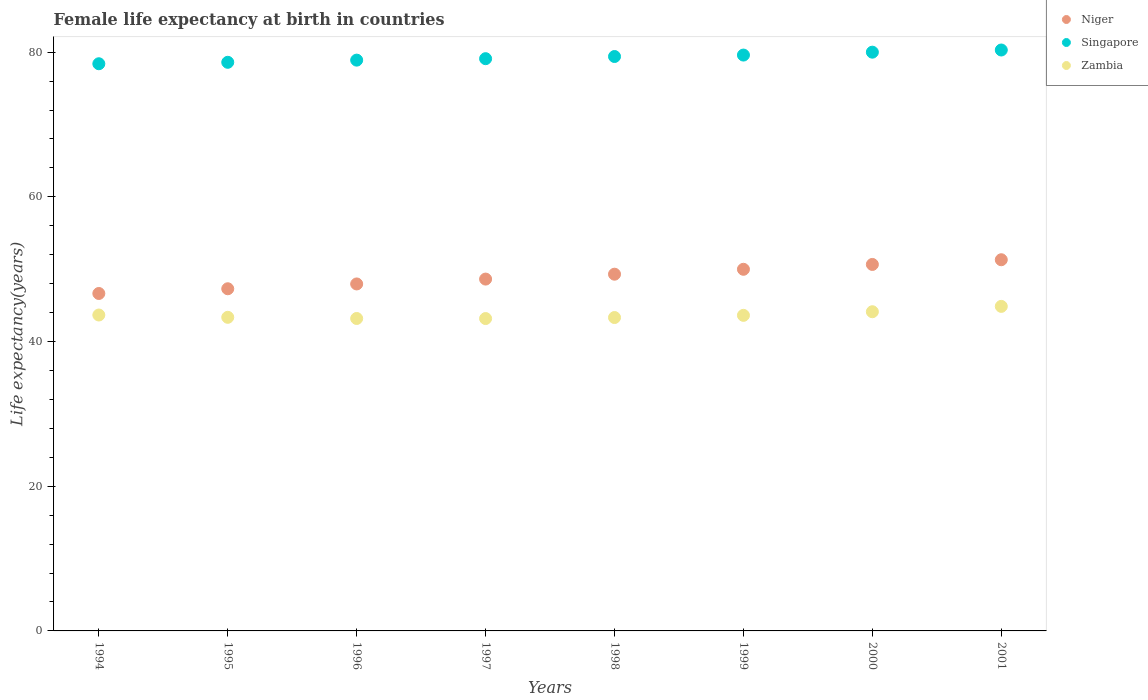How many different coloured dotlines are there?
Provide a short and direct response. 3. Is the number of dotlines equal to the number of legend labels?
Provide a short and direct response. Yes. What is the female life expectancy at birth in Niger in 1999?
Your response must be concise. 49.99. Across all years, what is the maximum female life expectancy at birth in Zambia?
Provide a succinct answer. 44.86. Across all years, what is the minimum female life expectancy at birth in Niger?
Keep it short and to the point. 46.64. In which year was the female life expectancy at birth in Singapore maximum?
Offer a very short reply. 2001. In which year was the female life expectancy at birth in Zambia minimum?
Your answer should be very brief. 1997. What is the total female life expectancy at birth in Zambia in the graph?
Make the answer very short. 349.31. What is the difference between the female life expectancy at birth in Niger in 1994 and that in 2000?
Make the answer very short. -4.01. What is the difference between the female life expectancy at birth in Niger in 1999 and the female life expectancy at birth in Singapore in 1996?
Your response must be concise. -28.91. What is the average female life expectancy at birth in Zambia per year?
Make the answer very short. 43.66. In the year 1996, what is the difference between the female life expectancy at birth in Zambia and female life expectancy at birth in Singapore?
Your answer should be compact. -35.71. In how many years, is the female life expectancy at birth in Niger greater than 32 years?
Your answer should be compact. 8. What is the ratio of the female life expectancy at birth in Zambia in 1996 to that in 1997?
Your response must be concise. 1. What is the difference between the highest and the second highest female life expectancy at birth in Singapore?
Your answer should be compact. 0.3. What is the difference between the highest and the lowest female life expectancy at birth in Zambia?
Keep it short and to the point. 1.68. Is the sum of the female life expectancy at birth in Niger in 1994 and 1997 greater than the maximum female life expectancy at birth in Zambia across all years?
Provide a short and direct response. Yes. Is the female life expectancy at birth in Singapore strictly less than the female life expectancy at birth in Niger over the years?
Provide a succinct answer. No. How many legend labels are there?
Offer a very short reply. 3. How are the legend labels stacked?
Your response must be concise. Vertical. What is the title of the graph?
Provide a succinct answer. Female life expectancy at birth in countries. Does "American Samoa" appear as one of the legend labels in the graph?
Offer a terse response. No. What is the label or title of the Y-axis?
Your answer should be compact. Life expectancy(years). What is the Life expectancy(years) of Niger in 1994?
Provide a short and direct response. 46.64. What is the Life expectancy(years) in Singapore in 1994?
Provide a succinct answer. 78.4. What is the Life expectancy(years) of Zambia in 1994?
Offer a terse response. 43.67. What is the Life expectancy(years) of Niger in 1995?
Make the answer very short. 47.3. What is the Life expectancy(years) of Singapore in 1995?
Your answer should be compact. 78.6. What is the Life expectancy(years) of Zambia in 1995?
Ensure brevity in your answer.  43.35. What is the Life expectancy(years) of Niger in 1996?
Give a very brief answer. 47.96. What is the Life expectancy(years) of Singapore in 1996?
Give a very brief answer. 78.9. What is the Life expectancy(years) in Zambia in 1996?
Provide a succinct answer. 43.19. What is the Life expectancy(years) in Niger in 1997?
Give a very brief answer. 48.63. What is the Life expectancy(years) in Singapore in 1997?
Offer a terse response. 79.1. What is the Life expectancy(years) of Zambia in 1997?
Your answer should be compact. 43.18. What is the Life expectancy(years) in Niger in 1998?
Make the answer very short. 49.31. What is the Life expectancy(years) of Singapore in 1998?
Offer a very short reply. 79.4. What is the Life expectancy(years) in Zambia in 1998?
Ensure brevity in your answer.  43.32. What is the Life expectancy(years) in Niger in 1999?
Offer a terse response. 49.99. What is the Life expectancy(years) of Singapore in 1999?
Offer a very short reply. 79.6. What is the Life expectancy(years) of Zambia in 1999?
Offer a terse response. 43.62. What is the Life expectancy(years) of Niger in 2000?
Provide a succinct answer. 50.66. What is the Life expectancy(years) in Zambia in 2000?
Your response must be concise. 44.12. What is the Life expectancy(years) in Niger in 2001?
Provide a short and direct response. 51.31. What is the Life expectancy(years) in Singapore in 2001?
Make the answer very short. 80.3. What is the Life expectancy(years) in Zambia in 2001?
Make the answer very short. 44.86. Across all years, what is the maximum Life expectancy(years) of Niger?
Provide a short and direct response. 51.31. Across all years, what is the maximum Life expectancy(years) in Singapore?
Give a very brief answer. 80.3. Across all years, what is the maximum Life expectancy(years) of Zambia?
Your response must be concise. 44.86. Across all years, what is the minimum Life expectancy(years) of Niger?
Your answer should be compact. 46.64. Across all years, what is the minimum Life expectancy(years) in Singapore?
Your answer should be compact. 78.4. Across all years, what is the minimum Life expectancy(years) in Zambia?
Make the answer very short. 43.18. What is the total Life expectancy(years) of Niger in the graph?
Ensure brevity in your answer.  391.8. What is the total Life expectancy(years) in Singapore in the graph?
Offer a terse response. 634.3. What is the total Life expectancy(years) of Zambia in the graph?
Your answer should be compact. 349.31. What is the difference between the Life expectancy(years) of Niger in 1994 and that in 1995?
Offer a terse response. -0.65. What is the difference between the Life expectancy(years) in Singapore in 1994 and that in 1995?
Provide a short and direct response. -0.2. What is the difference between the Life expectancy(years) in Zambia in 1994 and that in 1995?
Your answer should be compact. 0.32. What is the difference between the Life expectancy(years) of Niger in 1994 and that in 1996?
Keep it short and to the point. -1.32. What is the difference between the Life expectancy(years) in Singapore in 1994 and that in 1996?
Provide a succinct answer. -0.5. What is the difference between the Life expectancy(years) in Zambia in 1994 and that in 1996?
Keep it short and to the point. 0.48. What is the difference between the Life expectancy(years) in Niger in 1994 and that in 1997?
Make the answer very short. -1.99. What is the difference between the Life expectancy(years) in Zambia in 1994 and that in 1997?
Provide a succinct answer. 0.49. What is the difference between the Life expectancy(years) in Niger in 1994 and that in 1998?
Your answer should be very brief. -2.67. What is the difference between the Life expectancy(years) of Zambia in 1994 and that in 1998?
Offer a very short reply. 0.35. What is the difference between the Life expectancy(years) of Niger in 1994 and that in 1999?
Your answer should be very brief. -3.34. What is the difference between the Life expectancy(years) of Zambia in 1994 and that in 1999?
Your response must be concise. 0.05. What is the difference between the Life expectancy(years) of Niger in 1994 and that in 2000?
Offer a very short reply. -4.01. What is the difference between the Life expectancy(years) of Zambia in 1994 and that in 2000?
Offer a very short reply. -0.45. What is the difference between the Life expectancy(years) of Niger in 1994 and that in 2001?
Make the answer very short. -4.66. What is the difference between the Life expectancy(years) in Zambia in 1994 and that in 2001?
Offer a very short reply. -1.19. What is the difference between the Life expectancy(years) of Niger in 1995 and that in 1996?
Offer a very short reply. -0.67. What is the difference between the Life expectancy(years) in Singapore in 1995 and that in 1996?
Offer a terse response. -0.3. What is the difference between the Life expectancy(years) of Zambia in 1995 and that in 1996?
Your answer should be very brief. 0.16. What is the difference between the Life expectancy(years) in Niger in 1995 and that in 1997?
Your response must be concise. -1.34. What is the difference between the Life expectancy(years) of Zambia in 1995 and that in 1997?
Offer a terse response. 0.17. What is the difference between the Life expectancy(years) in Niger in 1995 and that in 1998?
Your answer should be very brief. -2.01. What is the difference between the Life expectancy(years) of Zambia in 1995 and that in 1998?
Your answer should be very brief. 0.03. What is the difference between the Life expectancy(years) in Niger in 1995 and that in 1999?
Provide a succinct answer. -2.69. What is the difference between the Life expectancy(years) in Zambia in 1995 and that in 1999?
Your response must be concise. -0.27. What is the difference between the Life expectancy(years) of Niger in 1995 and that in 2000?
Make the answer very short. -3.36. What is the difference between the Life expectancy(years) in Zambia in 1995 and that in 2000?
Provide a succinct answer. -0.77. What is the difference between the Life expectancy(years) in Niger in 1995 and that in 2001?
Your response must be concise. -4.01. What is the difference between the Life expectancy(years) of Singapore in 1995 and that in 2001?
Make the answer very short. -1.7. What is the difference between the Life expectancy(years) in Zambia in 1995 and that in 2001?
Give a very brief answer. -1.51. What is the difference between the Life expectancy(years) of Niger in 1996 and that in 1997?
Your answer should be very brief. -0.67. What is the difference between the Life expectancy(years) of Zambia in 1996 and that in 1997?
Make the answer very short. 0.01. What is the difference between the Life expectancy(years) of Niger in 1996 and that in 1998?
Your response must be concise. -1.35. What is the difference between the Life expectancy(years) in Zambia in 1996 and that in 1998?
Keep it short and to the point. -0.13. What is the difference between the Life expectancy(years) of Niger in 1996 and that in 1999?
Make the answer very short. -2.03. What is the difference between the Life expectancy(years) in Singapore in 1996 and that in 1999?
Your answer should be compact. -0.7. What is the difference between the Life expectancy(years) of Zambia in 1996 and that in 1999?
Your answer should be compact. -0.43. What is the difference between the Life expectancy(years) in Niger in 1996 and that in 2000?
Make the answer very short. -2.7. What is the difference between the Life expectancy(years) in Zambia in 1996 and that in 2000?
Give a very brief answer. -0.93. What is the difference between the Life expectancy(years) in Niger in 1996 and that in 2001?
Your answer should be compact. -3.35. What is the difference between the Life expectancy(years) in Zambia in 1996 and that in 2001?
Keep it short and to the point. -1.67. What is the difference between the Life expectancy(years) in Niger in 1997 and that in 1998?
Your answer should be very brief. -0.68. What is the difference between the Life expectancy(years) of Singapore in 1997 and that in 1998?
Make the answer very short. -0.3. What is the difference between the Life expectancy(years) in Zambia in 1997 and that in 1998?
Offer a terse response. -0.14. What is the difference between the Life expectancy(years) in Niger in 1997 and that in 1999?
Offer a terse response. -1.35. What is the difference between the Life expectancy(years) in Singapore in 1997 and that in 1999?
Provide a short and direct response. -0.5. What is the difference between the Life expectancy(years) in Zambia in 1997 and that in 1999?
Your response must be concise. -0.44. What is the difference between the Life expectancy(years) in Niger in 1997 and that in 2000?
Give a very brief answer. -2.02. What is the difference between the Life expectancy(years) in Zambia in 1997 and that in 2000?
Give a very brief answer. -0.94. What is the difference between the Life expectancy(years) in Niger in 1997 and that in 2001?
Offer a terse response. -2.67. What is the difference between the Life expectancy(years) of Zambia in 1997 and that in 2001?
Give a very brief answer. -1.68. What is the difference between the Life expectancy(years) in Niger in 1998 and that in 1999?
Your answer should be very brief. -0.68. What is the difference between the Life expectancy(years) in Zambia in 1998 and that in 1999?
Provide a short and direct response. -0.3. What is the difference between the Life expectancy(years) in Niger in 1998 and that in 2000?
Ensure brevity in your answer.  -1.35. What is the difference between the Life expectancy(years) in Zambia in 1998 and that in 2000?
Your answer should be compact. -0.8. What is the difference between the Life expectancy(years) in Niger in 1998 and that in 2001?
Offer a very short reply. -2. What is the difference between the Life expectancy(years) of Singapore in 1998 and that in 2001?
Provide a short and direct response. -0.9. What is the difference between the Life expectancy(years) of Zambia in 1998 and that in 2001?
Provide a succinct answer. -1.54. What is the difference between the Life expectancy(years) in Niger in 1999 and that in 2000?
Provide a succinct answer. -0.67. What is the difference between the Life expectancy(years) in Zambia in 1999 and that in 2000?
Your answer should be very brief. -0.5. What is the difference between the Life expectancy(years) of Niger in 1999 and that in 2001?
Offer a terse response. -1.32. What is the difference between the Life expectancy(years) of Singapore in 1999 and that in 2001?
Make the answer very short. -0.7. What is the difference between the Life expectancy(years) of Zambia in 1999 and that in 2001?
Offer a very short reply. -1.24. What is the difference between the Life expectancy(years) of Niger in 2000 and that in 2001?
Make the answer very short. -0.65. What is the difference between the Life expectancy(years) in Zambia in 2000 and that in 2001?
Offer a terse response. -0.74. What is the difference between the Life expectancy(years) in Niger in 1994 and the Life expectancy(years) in Singapore in 1995?
Your response must be concise. -31.96. What is the difference between the Life expectancy(years) of Niger in 1994 and the Life expectancy(years) of Zambia in 1995?
Offer a very short reply. 3.29. What is the difference between the Life expectancy(years) of Singapore in 1994 and the Life expectancy(years) of Zambia in 1995?
Keep it short and to the point. 35.05. What is the difference between the Life expectancy(years) in Niger in 1994 and the Life expectancy(years) in Singapore in 1996?
Ensure brevity in your answer.  -32.26. What is the difference between the Life expectancy(years) of Niger in 1994 and the Life expectancy(years) of Zambia in 1996?
Your response must be concise. 3.46. What is the difference between the Life expectancy(years) in Singapore in 1994 and the Life expectancy(years) in Zambia in 1996?
Your answer should be very brief. 35.21. What is the difference between the Life expectancy(years) in Niger in 1994 and the Life expectancy(years) in Singapore in 1997?
Provide a succinct answer. -32.46. What is the difference between the Life expectancy(years) in Niger in 1994 and the Life expectancy(years) in Zambia in 1997?
Your response must be concise. 3.46. What is the difference between the Life expectancy(years) in Singapore in 1994 and the Life expectancy(years) in Zambia in 1997?
Provide a short and direct response. 35.22. What is the difference between the Life expectancy(years) of Niger in 1994 and the Life expectancy(years) of Singapore in 1998?
Make the answer very short. -32.76. What is the difference between the Life expectancy(years) in Niger in 1994 and the Life expectancy(years) in Zambia in 1998?
Your answer should be compact. 3.33. What is the difference between the Life expectancy(years) of Singapore in 1994 and the Life expectancy(years) of Zambia in 1998?
Keep it short and to the point. 35.08. What is the difference between the Life expectancy(years) of Niger in 1994 and the Life expectancy(years) of Singapore in 1999?
Offer a terse response. -32.96. What is the difference between the Life expectancy(years) of Niger in 1994 and the Life expectancy(years) of Zambia in 1999?
Make the answer very short. 3.02. What is the difference between the Life expectancy(years) of Singapore in 1994 and the Life expectancy(years) of Zambia in 1999?
Provide a succinct answer. 34.78. What is the difference between the Life expectancy(years) of Niger in 1994 and the Life expectancy(years) of Singapore in 2000?
Your answer should be very brief. -33.36. What is the difference between the Life expectancy(years) of Niger in 1994 and the Life expectancy(years) of Zambia in 2000?
Give a very brief answer. 2.52. What is the difference between the Life expectancy(years) of Singapore in 1994 and the Life expectancy(years) of Zambia in 2000?
Make the answer very short. 34.28. What is the difference between the Life expectancy(years) of Niger in 1994 and the Life expectancy(years) of Singapore in 2001?
Offer a terse response. -33.66. What is the difference between the Life expectancy(years) in Niger in 1994 and the Life expectancy(years) in Zambia in 2001?
Your answer should be very brief. 1.78. What is the difference between the Life expectancy(years) of Singapore in 1994 and the Life expectancy(years) of Zambia in 2001?
Keep it short and to the point. 33.54. What is the difference between the Life expectancy(years) of Niger in 1995 and the Life expectancy(years) of Singapore in 1996?
Provide a short and direct response. -31.6. What is the difference between the Life expectancy(years) in Niger in 1995 and the Life expectancy(years) in Zambia in 1996?
Ensure brevity in your answer.  4.11. What is the difference between the Life expectancy(years) in Singapore in 1995 and the Life expectancy(years) in Zambia in 1996?
Offer a very short reply. 35.41. What is the difference between the Life expectancy(years) in Niger in 1995 and the Life expectancy(years) in Singapore in 1997?
Make the answer very short. -31.8. What is the difference between the Life expectancy(years) of Niger in 1995 and the Life expectancy(years) of Zambia in 1997?
Your response must be concise. 4.12. What is the difference between the Life expectancy(years) of Singapore in 1995 and the Life expectancy(years) of Zambia in 1997?
Provide a succinct answer. 35.42. What is the difference between the Life expectancy(years) of Niger in 1995 and the Life expectancy(years) of Singapore in 1998?
Your answer should be very brief. -32.1. What is the difference between the Life expectancy(years) in Niger in 1995 and the Life expectancy(years) in Zambia in 1998?
Provide a succinct answer. 3.98. What is the difference between the Life expectancy(years) in Singapore in 1995 and the Life expectancy(years) in Zambia in 1998?
Make the answer very short. 35.28. What is the difference between the Life expectancy(years) in Niger in 1995 and the Life expectancy(years) in Singapore in 1999?
Ensure brevity in your answer.  -32.3. What is the difference between the Life expectancy(years) in Niger in 1995 and the Life expectancy(years) in Zambia in 1999?
Offer a terse response. 3.68. What is the difference between the Life expectancy(years) of Singapore in 1995 and the Life expectancy(years) of Zambia in 1999?
Provide a short and direct response. 34.98. What is the difference between the Life expectancy(years) in Niger in 1995 and the Life expectancy(years) in Singapore in 2000?
Your answer should be very brief. -32.7. What is the difference between the Life expectancy(years) in Niger in 1995 and the Life expectancy(years) in Zambia in 2000?
Keep it short and to the point. 3.18. What is the difference between the Life expectancy(years) in Singapore in 1995 and the Life expectancy(years) in Zambia in 2000?
Provide a succinct answer. 34.48. What is the difference between the Life expectancy(years) of Niger in 1995 and the Life expectancy(years) of Singapore in 2001?
Your answer should be compact. -33. What is the difference between the Life expectancy(years) in Niger in 1995 and the Life expectancy(years) in Zambia in 2001?
Offer a very short reply. 2.44. What is the difference between the Life expectancy(years) in Singapore in 1995 and the Life expectancy(years) in Zambia in 2001?
Give a very brief answer. 33.74. What is the difference between the Life expectancy(years) of Niger in 1996 and the Life expectancy(years) of Singapore in 1997?
Provide a short and direct response. -31.14. What is the difference between the Life expectancy(years) of Niger in 1996 and the Life expectancy(years) of Zambia in 1997?
Your response must be concise. 4.78. What is the difference between the Life expectancy(years) of Singapore in 1996 and the Life expectancy(years) of Zambia in 1997?
Offer a very short reply. 35.72. What is the difference between the Life expectancy(years) of Niger in 1996 and the Life expectancy(years) of Singapore in 1998?
Provide a short and direct response. -31.44. What is the difference between the Life expectancy(years) of Niger in 1996 and the Life expectancy(years) of Zambia in 1998?
Keep it short and to the point. 4.64. What is the difference between the Life expectancy(years) in Singapore in 1996 and the Life expectancy(years) in Zambia in 1998?
Ensure brevity in your answer.  35.58. What is the difference between the Life expectancy(years) in Niger in 1996 and the Life expectancy(years) in Singapore in 1999?
Provide a succinct answer. -31.64. What is the difference between the Life expectancy(years) in Niger in 1996 and the Life expectancy(years) in Zambia in 1999?
Keep it short and to the point. 4.34. What is the difference between the Life expectancy(years) in Singapore in 1996 and the Life expectancy(years) in Zambia in 1999?
Provide a succinct answer. 35.28. What is the difference between the Life expectancy(years) in Niger in 1996 and the Life expectancy(years) in Singapore in 2000?
Your answer should be very brief. -32.04. What is the difference between the Life expectancy(years) of Niger in 1996 and the Life expectancy(years) of Zambia in 2000?
Your response must be concise. 3.84. What is the difference between the Life expectancy(years) in Singapore in 1996 and the Life expectancy(years) in Zambia in 2000?
Provide a succinct answer. 34.78. What is the difference between the Life expectancy(years) in Niger in 1996 and the Life expectancy(years) in Singapore in 2001?
Provide a short and direct response. -32.34. What is the difference between the Life expectancy(years) of Niger in 1996 and the Life expectancy(years) of Zambia in 2001?
Ensure brevity in your answer.  3.1. What is the difference between the Life expectancy(years) of Singapore in 1996 and the Life expectancy(years) of Zambia in 2001?
Keep it short and to the point. 34.04. What is the difference between the Life expectancy(years) in Niger in 1997 and the Life expectancy(years) in Singapore in 1998?
Make the answer very short. -30.77. What is the difference between the Life expectancy(years) of Niger in 1997 and the Life expectancy(years) of Zambia in 1998?
Offer a terse response. 5.32. What is the difference between the Life expectancy(years) in Singapore in 1997 and the Life expectancy(years) in Zambia in 1998?
Your answer should be compact. 35.78. What is the difference between the Life expectancy(years) of Niger in 1997 and the Life expectancy(years) of Singapore in 1999?
Keep it short and to the point. -30.97. What is the difference between the Life expectancy(years) of Niger in 1997 and the Life expectancy(years) of Zambia in 1999?
Offer a very short reply. 5.01. What is the difference between the Life expectancy(years) of Singapore in 1997 and the Life expectancy(years) of Zambia in 1999?
Your answer should be very brief. 35.48. What is the difference between the Life expectancy(years) of Niger in 1997 and the Life expectancy(years) of Singapore in 2000?
Offer a terse response. -31.37. What is the difference between the Life expectancy(years) of Niger in 1997 and the Life expectancy(years) of Zambia in 2000?
Give a very brief answer. 4.51. What is the difference between the Life expectancy(years) of Singapore in 1997 and the Life expectancy(years) of Zambia in 2000?
Give a very brief answer. 34.98. What is the difference between the Life expectancy(years) in Niger in 1997 and the Life expectancy(years) in Singapore in 2001?
Offer a terse response. -31.67. What is the difference between the Life expectancy(years) in Niger in 1997 and the Life expectancy(years) in Zambia in 2001?
Your answer should be compact. 3.77. What is the difference between the Life expectancy(years) in Singapore in 1997 and the Life expectancy(years) in Zambia in 2001?
Your response must be concise. 34.24. What is the difference between the Life expectancy(years) in Niger in 1998 and the Life expectancy(years) in Singapore in 1999?
Your answer should be very brief. -30.29. What is the difference between the Life expectancy(years) of Niger in 1998 and the Life expectancy(years) of Zambia in 1999?
Your answer should be compact. 5.69. What is the difference between the Life expectancy(years) in Singapore in 1998 and the Life expectancy(years) in Zambia in 1999?
Make the answer very short. 35.78. What is the difference between the Life expectancy(years) in Niger in 1998 and the Life expectancy(years) in Singapore in 2000?
Make the answer very short. -30.69. What is the difference between the Life expectancy(years) in Niger in 1998 and the Life expectancy(years) in Zambia in 2000?
Offer a terse response. 5.19. What is the difference between the Life expectancy(years) in Singapore in 1998 and the Life expectancy(years) in Zambia in 2000?
Provide a short and direct response. 35.28. What is the difference between the Life expectancy(years) of Niger in 1998 and the Life expectancy(years) of Singapore in 2001?
Give a very brief answer. -30.99. What is the difference between the Life expectancy(years) in Niger in 1998 and the Life expectancy(years) in Zambia in 2001?
Keep it short and to the point. 4.45. What is the difference between the Life expectancy(years) in Singapore in 1998 and the Life expectancy(years) in Zambia in 2001?
Ensure brevity in your answer.  34.54. What is the difference between the Life expectancy(years) of Niger in 1999 and the Life expectancy(years) of Singapore in 2000?
Offer a terse response. -30.01. What is the difference between the Life expectancy(years) in Niger in 1999 and the Life expectancy(years) in Zambia in 2000?
Provide a succinct answer. 5.87. What is the difference between the Life expectancy(years) of Singapore in 1999 and the Life expectancy(years) of Zambia in 2000?
Keep it short and to the point. 35.48. What is the difference between the Life expectancy(years) of Niger in 1999 and the Life expectancy(years) of Singapore in 2001?
Ensure brevity in your answer.  -30.31. What is the difference between the Life expectancy(years) of Niger in 1999 and the Life expectancy(years) of Zambia in 2001?
Your answer should be very brief. 5.13. What is the difference between the Life expectancy(years) in Singapore in 1999 and the Life expectancy(years) in Zambia in 2001?
Provide a succinct answer. 34.74. What is the difference between the Life expectancy(years) in Niger in 2000 and the Life expectancy(years) in Singapore in 2001?
Provide a short and direct response. -29.64. What is the difference between the Life expectancy(years) in Niger in 2000 and the Life expectancy(years) in Zambia in 2001?
Provide a short and direct response. 5.8. What is the difference between the Life expectancy(years) in Singapore in 2000 and the Life expectancy(years) in Zambia in 2001?
Make the answer very short. 35.14. What is the average Life expectancy(years) in Niger per year?
Make the answer very short. 48.98. What is the average Life expectancy(years) in Singapore per year?
Keep it short and to the point. 79.29. What is the average Life expectancy(years) of Zambia per year?
Give a very brief answer. 43.66. In the year 1994, what is the difference between the Life expectancy(years) of Niger and Life expectancy(years) of Singapore?
Your answer should be very brief. -31.76. In the year 1994, what is the difference between the Life expectancy(years) in Niger and Life expectancy(years) in Zambia?
Your response must be concise. 2.98. In the year 1994, what is the difference between the Life expectancy(years) of Singapore and Life expectancy(years) of Zambia?
Your answer should be compact. 34.73. In the year 1995, what is the difference between the Life expectancy(years) in Niger and Life expectancy(years) in Singapore?
Offer a terse response. -31.3. In the year 1995, what is the difference between the Life expectancy(years) of Niger and Life expectancy(years) of Zambia?
Your response must be concise. 3.95. In the year 1995, what is the difference between the Life expectancy(years) of Singapore and Life expectancy(years) of Zambia?
Keep it short and to the point. 35.25. In the year 1996, what is the difference between the Life expectancy(years) in Niger and Life expectancy(years) in Singapore?
Offer a terse response. -30.94. In the year 1996, what is the difference between the Life expectancy(years) in Niger and Life expectancy(years) in Zambia?
Keep it short and to the point. 4.77. In the year 1996, what is the difference between the Life expectancy(years) in Singapore and Life expectancy(years) in Zambia?
Offer a very short reply. 35.71. In the year 1997, what is the difference between the Life expectancy(years) in Niger and Life expectancy(years) in Singapore?
Keep it short and to the point. -30.47. In the year 1997, what is the difference between the Life expectancy(years) in Niger and Life expectancy(years) in Zambia?
Provide a short and direct response. 5.46. In the year 1997, what is the difference between the Life expectancy(years) in Singapore and Life expectancy(years) in Zambia?
Keep it short and to the point. 35.92. In the year 1998, what is the difference between the Life expectancy(years) in Niger and Life expectancy(years) in Singapore?
Your response must be concise. -30.09. In the year 1998, what is the difference between the Life expectancy(years) of Niger and Life expectancy(years) of Zambia?
Make the answer very short. 5.99. In the year 1998, what is the difference between the Life expectancy(years) of Singapore and Life expectancy(years) of Zambia?
Make the answer very short. 36.08. In the year 1999, what is the difference between the Life expectancy(years) of Niger and Life expectancy(years) of Singapore?
Your response must be concise. -29.61. In the year 1999, what is the difference between the Life expectancy(years) of Niger and Life expectancy(years) of Zambia?
Offer a terse response. 6.37. In the year 1999, what is the difference between the Life expectancy(years) of Singapore and Life expectancy(years) of Zambia?
Provide a succinct answer. 35.98. In the year 2000, what is the difference between the Life expectancy(years) in Niger and Life expectancy(years) in Singapore?
Provide a short and direct response. -29.34. In the year 2000, what is the difference between the Life expectancy(years) of Niger and Life expectancy(years) of Zambia?
Make the answer very short. 6.54. In the year 2000, what is the difference between the Life expectancy(years) of Singapore and Life expectancy(years) of Zambia?
Keep it short and to the point. 35.88. In the year 2001, what is the difference between the Life expectancy(years) in Niger and Life expectancy(years) in Singapore?
Offer a very short reply. -28.99. In the year 2001, what is the difference between the Life expectancy(years) of Niger and Life expectancy(years) of Zambia?
Provide a succinct answer. 6.45. In the year 2001, what is the difference between the Life expectancy(years) of Singapore and Life expectancy(years) of Zambia?
Keep it short and to the point. 35.44. What is the ratio of the Life expectancy(years) of Niger in 1994 to that in 1995?
Your response must be concise. 0.99. What is the ratio of the Life expectancy(years) in Singapore in 1994 to that in 1995?
Ensure brevity in your answer.  1. What is the ratio of the Life expectancy(years) of Zambia in 1994 to that in 1995?
Provide a succinct answer. 1.01. What is the ratio of the Life expectancy(years) of Niger in 1994 to that in 1996?
Provide a succinct answer. 0.97. What is the ratio of the Life expectancy(years) of Zambia in 1994 to that in 1996?
Your answer should be very brief. 1.01. What is the ratio of the Life expectancy(years) in Niger in 1994 to that in 1997?
Offer a terse response. 0.96. What is the ratio of the Life expectancy(years) of Zambia in 1994 to that in 1997?
Your answer should be very brief. 1.01. What is the ratio of the Life expectancy(years) of Niger in 1994 to that in 1998?
Provide a succinct answer. 0.95. What is the ratio of the Life expectancy(years) in Singapore in 1994 to that in 1998?
Give a very brief answer. 0.99. What is the ratio of the Life expectancy(years) in Zambia in 1994 to that in 1998?
Your response must be concise. 1.01. What is the ratio of the Life expectancy(years) in Niger in 1994 to that in 1999?
Your answer should be compact. 0.93. What is the ratio of the Life expectancy(years) of Singapore in 1994 to that in 1999?
Provide a short and direct response. 0.98. What is the ratio of the Life expectancy(years) of Zambia in 1994 to that in 1999?
Ensure brevity in your answer.  1. What is the ratio of the Life expectancy(years) in Niger in 1994 to that in 2000?
Provide a short and direct response. 0.92. What is the ratio of the Life expectancy(years) in Singapore in 1994 to that in 2000?
Offer a terse response. 0.98. What is the ratio of the Life expectancy(years) in Zambia in 1994 to that in 2000?
Keep it short and to the point. 0.99. What is the ratio of the Life expectancy(years) in Singapore in 1994 to that in 2001?
Your response must be concise. 0.98. What is the ratio of the Life expectancy(years) in Zambia in 1994 to that in 2001?
Ensure brevity in your answer.  0.97. What is the ratio of the Life expectancy(years) in Niger in 1995 to that in 1996?
Make the answer very short. 0.99. What is the ratio of the Life expectancy(years) of Zambia in 1995 to that in 1996?
Give a very brief answer. 1. What is the ratio of the Life expectancy(years) of Niger in 1995 to that in 1997?
Ensure brevity in your answer.  0.97. What is the ratio of the Life expectancy(years) of Singapore in 1995 to that in 1997?
Offer a very short reply. 0.99. What is the ratio of the Life expectancy(years) in Zambia in 1995 to that in 1997?
Provide a succinct answer. 1. What is the ratio of the Life expectancy(years) in Niger in 1995 to that in 1998?
Provide a short and direct response. 0.96. What is the ratio of the Life expectancy(years) of Niger in 1995 to that in 1999?
Ensure brevity in your answer.  0.95. What is the ratio of the Life expectancy(years) of Singapore in 1995 to that in 1999?
Offer a very short reply. 0.99. What is the ratio of the Life expectancy(years) of Niger in 1995 to that in 2000?
Make the answer very short. 0.93. What is the ratio of the Life expectancy(years) in Singapore in 1995 to that in 2000?
Your answer should be very brief. 0.98. What is the ratio of the Life expectancy(years) in Zambia in 1995 to that in 2000?
Ensure brevity in your answer.  0.98. What is the ratio of the Life expectancy(years) of Niger in 1995 to that in 2001?
Provide a short and direct response. 0.92. What is the ratio of the Life expectancy(years) of Singapore in 1995 to that in 2001?
Offer a very short reply. 0.98. What is the ratio of the Life expectancy(years) of Zambia in 1995 to that in 2001?
Your answer should be very brief. 0.97. What is the ratio of the Life expectancy(years) in Niger in 1996 to that in 1997?
Your response must be concise. 0.99. What is the ratio of the Life expectancy(years) of Zambia in 1996 to that in 1997?
Give a very brief answer. 1. What is the ratio of the Life expectancy(years) in Niger in 1996 to that in 1998?
Your response must be concise. 0.97. What is the ratio of the Life expectancy(years) of Singapore in 1996 to that in 1998?
Offer a terse response. 0.99. What is the ratio of the Life expectancy(years) in Niger in 1996 to that in 1999?
Keep it short and to the point. 0.96. What is the ratio of the Life expectancy(years) in Singapore in 1996 to that in 1999?
Your answer should be compact. 0.99. What is the ratio of the Life expectancy(years) in Zambia in 1996 to that in 1999?
Make the answer very short. 0.99. What is the ratio of the Life expectancy(years) of Niger in 1996 to that in 2000?
Offer a very short reply. 0.95. What is the ratio of the Life expectancy(years) in Singapore in 1996 to that in 2000?
Provide a short and direct response. 0.99. What is the ratio of the Life expectancy(years) of Zambia in 1996 to that in 2000?
Your answer should be compact. 0.98. What is the ratio of the Life expectancy(years) of Niger in 1996 to that in 2001?
Ensure brevity in your answer.  0.93. What is the ratio of the Life expectancy(years) in Singapore in 1996 to that in 2001?
Provide a succinct answer. 0.98. What is the ratio of the Life expectancy(years) in Zambia in 1996 to that in 2001?
Give a very brief answer. 0.96. What is the ratio of the Life expectancy(years) of Niger in 1997 to that in 1998?
Offer a very short reply. 0.99. What is the ratio of the Life expectancy(years) in Singapore in 1997 to that in 1998?
Provide a succinct answer. 1. What is the ratio of the Life expectancy(years) of Niger in 1997 to that in 1999?
Make the answer very short. 0.97. What is the ratio of the Life expectancy(years) of Singapore in 1997 to that in 1999?
Your answer should be compact. 0.99. What is the ratio of the Life expectancy(years) of Niger in 1997 to that in 2000?
Make the answer very short. 0.96. What is the ratio of the Life expectancy(years) of Singapore in 1997 to that in 2000?
Provide a short and direct response. 0.99. What is the ratio of the Life expectancy(years) in Zambia in 1997 to that in 2000?
Your answer should be compact. 0.98. What is the ratio of the Life expectancy(years) in Niger in 1997 to that in 2001?
Provide a short and direct response. 0.95. What is the ratio of the Life expectancy(years) in Singapore in 1997 to that in 2001?
Ensure brevity in your answer.  0.99. What is the ratio of the Life expectancy(years) of Zambia in 1997 to that in 2001?
Your response must be concise. 0.96. What is the ratio of the Life expectancy(years) in Niger in 1998 to that in 1999?
Offer a terse response. 0.99. What is the ratio of the Life expectancy(years) of Zambia in 1998 to that in 1999?
Your response must be concise. 0.99. What is the ratio of the Life expectancy(years) in Niger in 1998 to that in 2000?
Provide a succinct answer. 0.97. What is the ratio of the Life expectancy(years) in Singapore in 1998 to that in 2000?
Provide a short and direct response. 0.99. What is the ratio of the Life expectancy(years) in Zambia in 1998 to that in 2000?
Ensure brevity in your answer.  0.98. What is the ratio of the Life expectancy(years) in Niger in 1998 to that in 2001?
Ensure brevity in your answer.  0.96. What is the ratio of the Life expectancy(years) of Zambia in 1998 to that in 2001?
Offer a very short reply. 0.97. What is the ratio of the Life expectancy(years) in Niger in 1999 to that in 2000?
Your answer should be very brief. 0.99. What is the ratio of the Life expectancy(years) in Zambia in 1999 to that in 2000?
Provide a succinct answer. 0.99. What is the ratio of the Life expectancy(years) in Niger in 1999 to that in 2001?
Offer a very short reply. 0.97. What is the ratio of the Life expectancy(years) in Zambia in 1999 to that in 2001?
Your response must be concise. 0.97. What is the ratio of the Life expectancy(years) in Niger in 2000 to that in 2001?
Offer a very short reply. 0.99. What is the ratio of the Life expectancy(years) in Zambia in 2000 to that in 2001?
Your answer should be very brief. 0.98. What is the difference between the highest and the second highest Life expectancy(years) of Niger?
Your response must be concise. 0.65. What is the difference between the highest and the second highest Life expectancy(years) in Zambia?
Your answer should be very brief. 0.74. What is the difference between the highest and the lowest Life expectancy(years) of Niger?
Your answer should be very brief. 4.66. What is the difference between the highest and the lowest Life expectancy(years) of Zambia?
Ensure brevity in your answer.  1.68. 